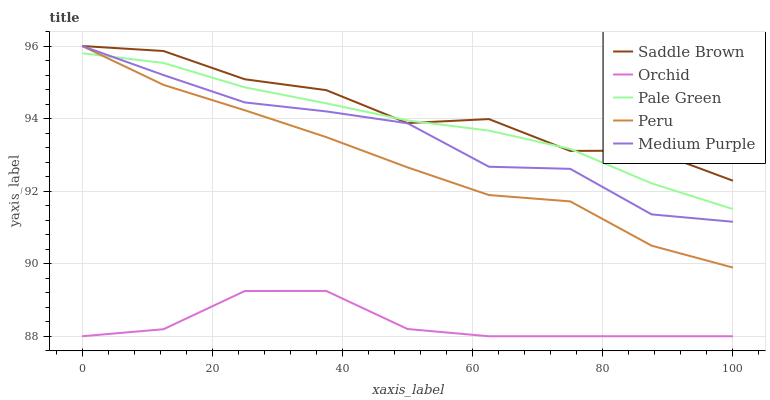Does Orchid have the minimum area under the curve?
Answer yes or no. Yes. Does Saddle Brown have the maximum area under the curve?
Answer yes or no. Yes. Does Pale Green have the minimum area under the curve?
Answer yes or no. No. Does Pale Green have the maximum area under the curve?
Answer yes or no. No. Is Pale Green the smoothest?
Answer yes or no. Yes. Is Saddle Brown the roughest?
Answer yes or no. Yes. Is Saddle Brown the smoothest?
Answer yes or no. No. Is Pale Green the roughest?
Answer yes or no. No. Does Pale Green have the lowest value?
Answer yes or no. No. Does Pale Green have the highest value?
Answer yes or no. No. Is Orchid less than Saddle Brown?
Answer yes or no. Yes. Is Pale Green greater than Orchid?
Answer yes or no. Yes. Does Orchid intersect Saddle Brown?
Answer yes or no. No. 